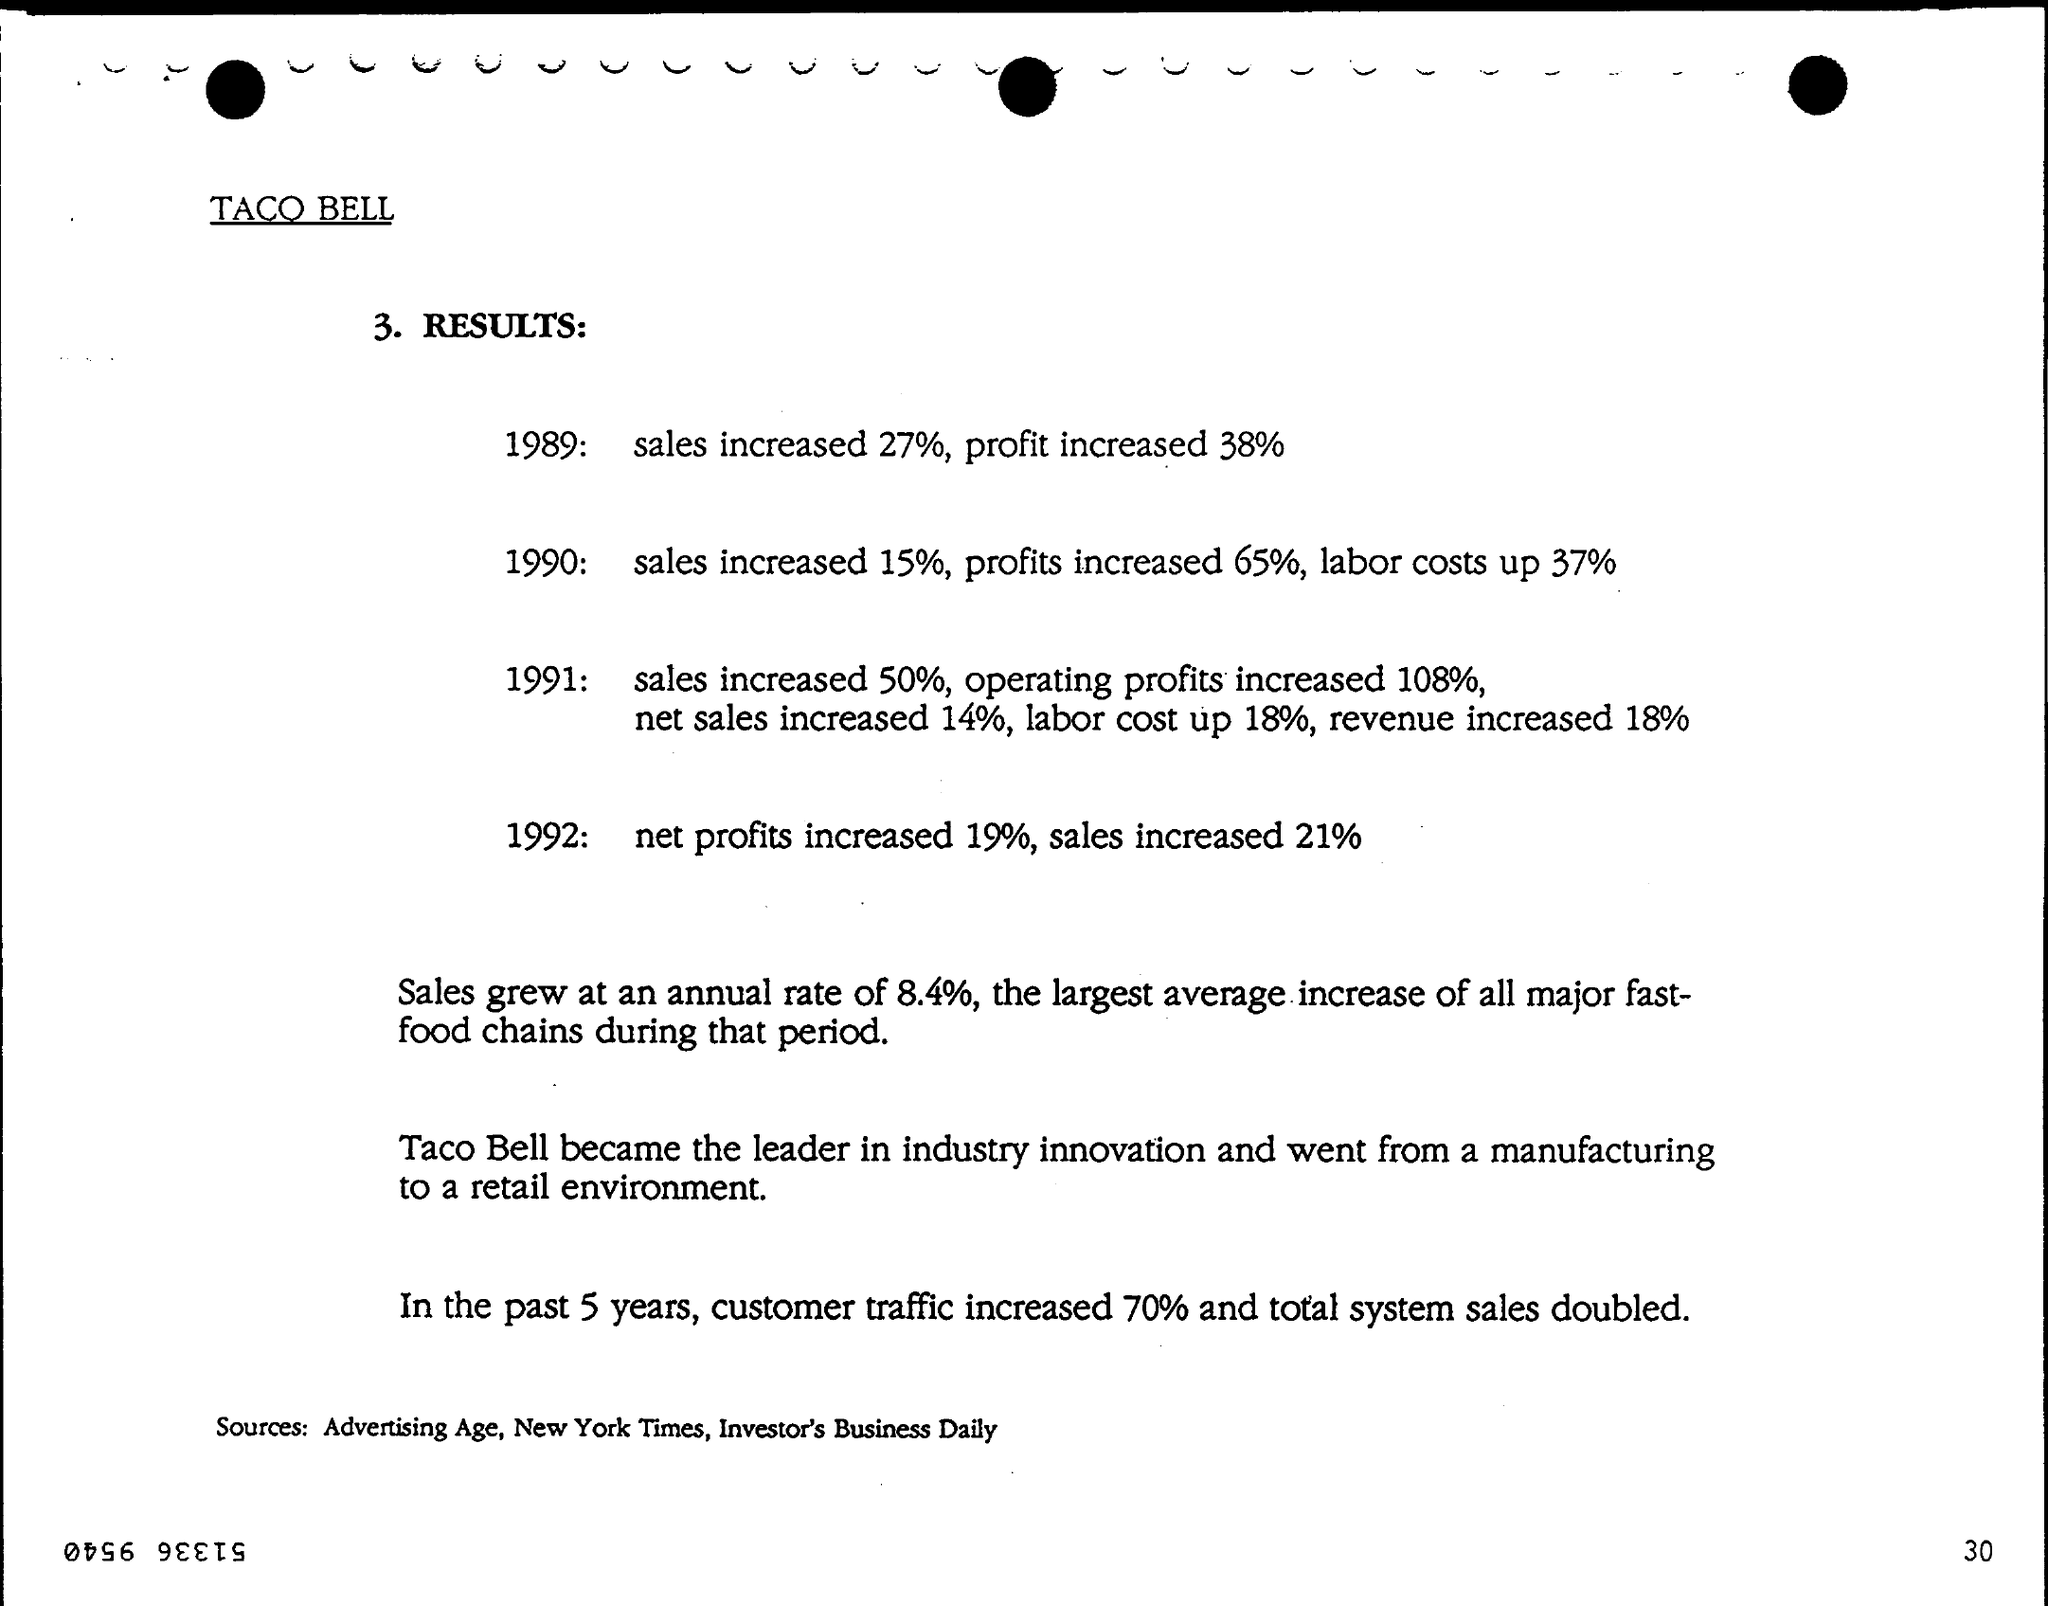In 1989 how much sales increased ?
Ensure brevity in your answer.  Sales increased 27%,. How much net profits increased in 1992 ?
Make the answer very short. Net profits increased 19%. In the past 5 years, how much customer traffic increased ?
Your answer should be compact. Customer traffic increased 70%. What is the Labour cost up in 1991 ?
Offer a very short reply. Labour cost up 18%. How much profit increased in 1990 ?
Provide a succinct answer. 65%. Who is the Leader in industry innovation ?
Your answer should be very brief. Taco Bell. 